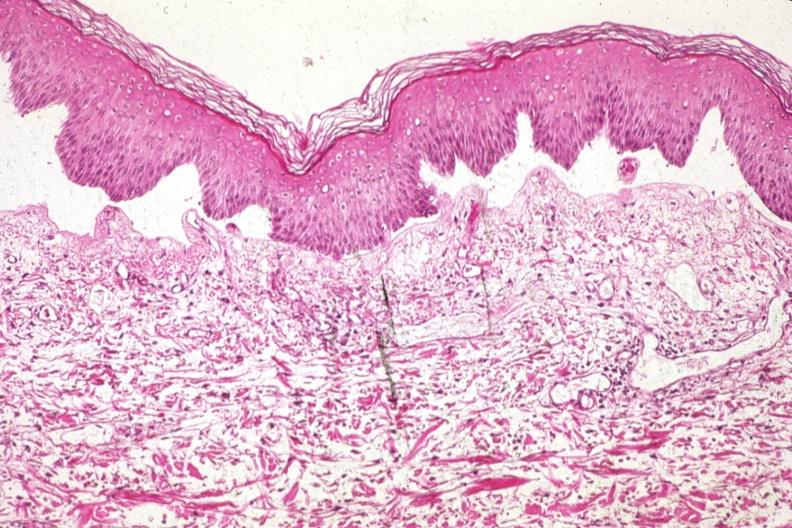does this image show med excellent example of epidermal separation gross of this lesion is 907?
Answer the question using a single word or phrase. Yes 